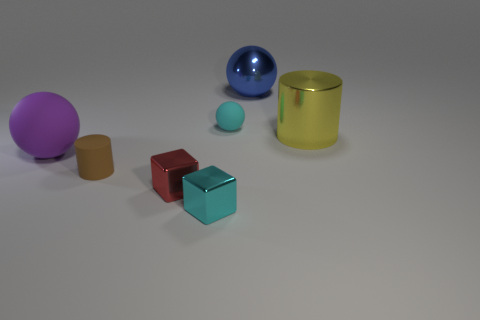Subtract all large blue spheres. How many spheres are left? 2 Add 3 tiny cyan blocks. How many objects exist? 10 Subtract all purple balls. How many balls are left? 2 Subtract all cylinders. How many objects are left? 5 Subtract all gray cylinders. How many gray blocks are left? 0 Subtract all blue metal spheres. Subtract all cyan matte things. How many objects are left? 5 Add 7 large rubber objects. How many large rubber objects are left? 8 Add 4 matte blocks. How many matte blocks exist? 4 Subtract 1 brown cylinders. How many objects are left? 6 Subtract 2 cylinders. How many cylinders are left? 0 